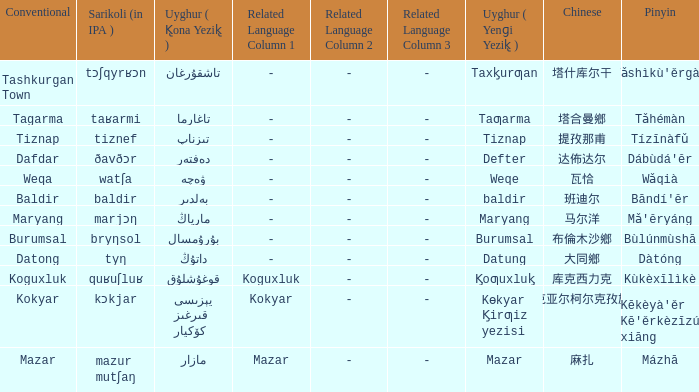Name the conventional for defter Dafdar. 